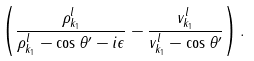Convert formula to latex. <formula><loc_0><loc_0><loc_500><loc_500>\left ( \frac { \rho _ { { k } _ { 1 } } ^ { l } } { \rho _ { { k } _ { 1 } } ^ { l } - \cos \theta ^ { \prime } - i \epsilon } - \frac { v _ { { k } _ { 1 } } ^ { l } } { v _ { { k } _ { 1 } } ^ { l } - \cos \theta ^ { \prime } } \right ) .</formula> 